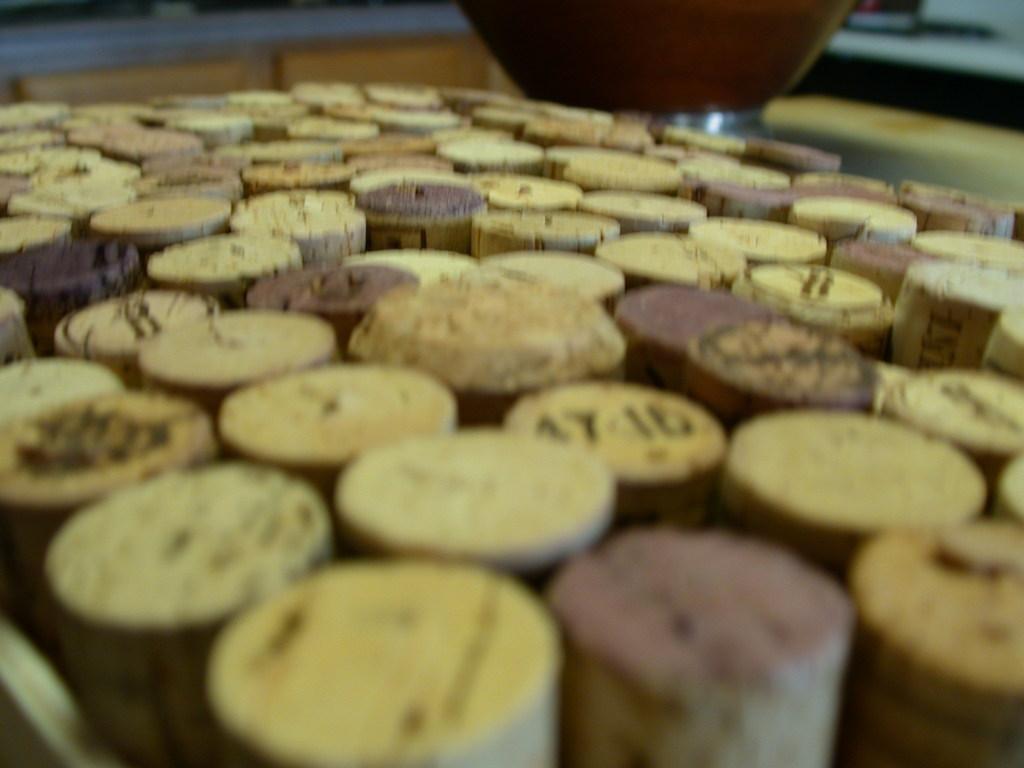How would you summarize this image in a sentence or two? There are many corks. 